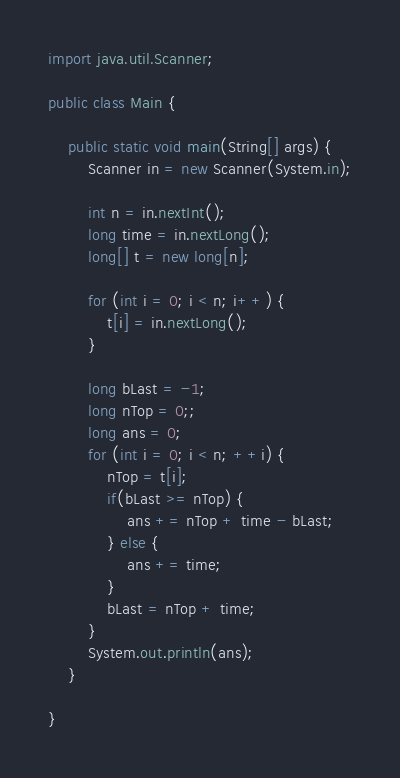Convert code to text. <code><loc_0><loc_0><loc_500><loc_500><_Java_>import java.util.Scanner;

public class Main {

	public static void main(String[] args) {
		Scanner in = new Scanner(System.in);

		int n = in.nextInt();
		long time = in.nextLong();
		long[] t = new long[n];

		for (int i = 0; i < n; i++) {
			t[i] = in.nextLong();
		}

		long bLast = -1;
		long nTop = 0;;
		long ans = 0;
		for (int i = 0; i < n; ++i) {
			nTop = t[i];
			if(bLast >= nTop) {
				ans += nTop + time - bLast;
			} else {
				ans += time;
			}
			bLast = nTop + time;
		}
		System.out.println(ans);
	}

}
</code> 